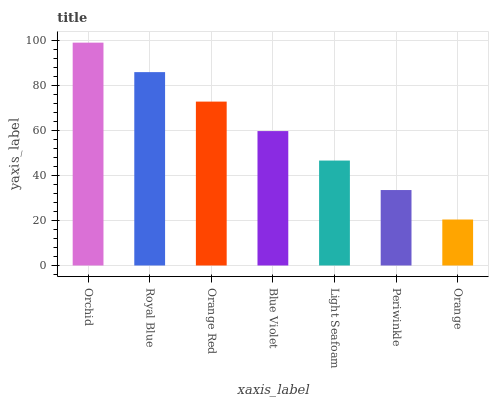Is Orange the minimum?
Answer yes or no. Yes. Is Orchid the maximum?
Answer yes or no. Yes. Is Royal Blue the minimum?
Answer yes or no. No. Is Royal Blue the maximum?
Answer yes or no. No. Is Orchid greater than Royal Blue?
Answer yes or no. Yes. Is Royal Blue less than Orchid?
Answer yes or no. Yes. Is Royal Blue greater than Orchid?
Answer yes or no. No. Is Orchid less than Royal Blue?
Answer yes or no. No. Is Blue Violet the high median?
Answer yes or no. Yes. Is Blue Violet the low median?
Answer yes or no. Yes. Is Light Seafoam the high median?
Answer yes or no. No. Is Orchid the low median?
Answer yes or no. No. 